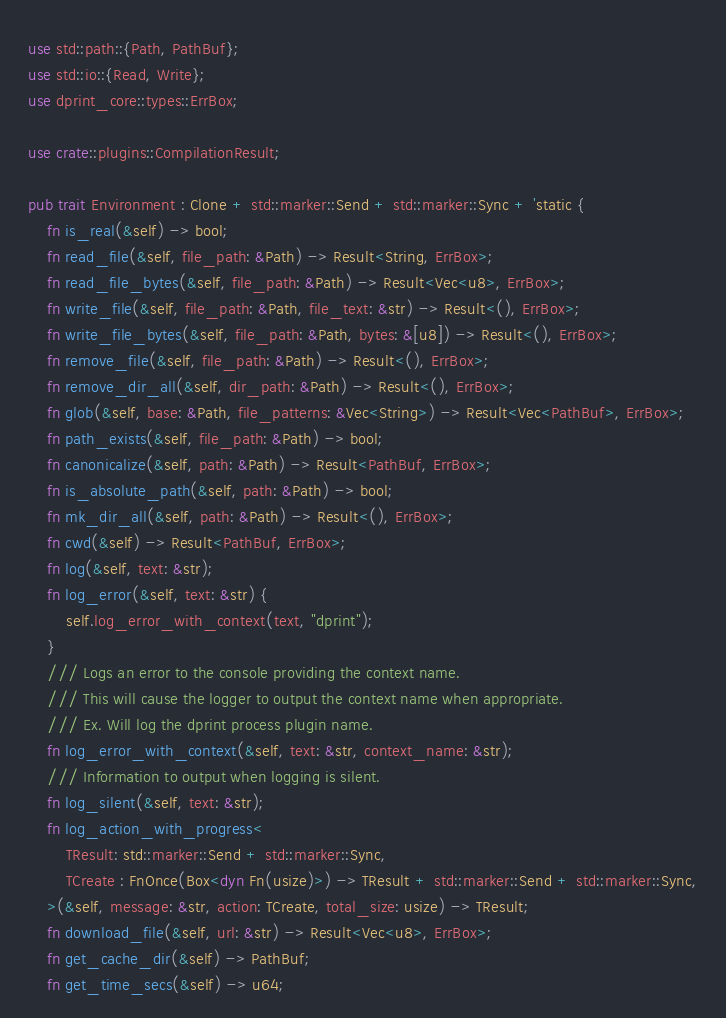<code> <loc_0><loc_0><loc_500><loc_500><_Rust_>use std::path::{Path, PathBuf};
use std::io::{Read, Write};
use dprint_core::types::ErrBox;

use crate::plugins::CompilationResult;

pub trait Environment : Clone + std::marker::Send + std::marker::Sync + 'static {
    fn is_real(&self) -> bool;
    fn read_file(&self, file_path: &Path) -> Result<String, ErrBox>;
    fn read_file_bytes(&self, file_path: &Path) -> Result<Vec<u8>, ErrBox>;
    fn write_file(&self, file_path: &Path, file_text: &str) -> Result<(), ErrBox>;
    fn write_file_bytes(&self, file_path: &Path, bytes: &[u8]) -> Result<(), ErrBox>;
    fn remove_file(&self, file_path: &Path) -> Result<(), ErrBox>;
    fn remove_dir_all(&self, dir_path: &Path) -> Result<(), ErrBox>;
    fn glob(&self, base: &Path, file_patterns: &Vec<String>) -> Result<Vec<PathBuf>, ErrBox>;
    fn path_exists(&self, file_path: &Path) -> bool;
    fn canonicalize(&self, path: &Path) -> Result<PathBuf, ErrBox>;
    fn is_absolute_path(&self, path: &Path) -> bool;
    fn mk_dir_all(&self, path: &Path) -> Result<(), ErrBox>;
    fn cwd(&self) -> Result<PathBuf, ErrBox>;
    fn log(&self, text: &str);
    fn log_error(&self, text: &str) {
        self.log_error_with_context(text, "dprint");
    }
    /// Logs an error to the console providing the context name.
    /// This will cause the logger to output the context name when appropriate.
    /// Ex. Will log the dprint process plugin name.
    fn log_error_with_context(&self, text: &str, context_name: &str);
    /// Information to output when logging is silent.
    fn log_silent(&self, text: &str);
    fn log_action_with_progress<
        TResult: std::marker::Send + std::marker::Sync,
        TCreate : FnOnce(Box<dyn Fn(usize)>) -> TResult + std::marker::Send + std::marker::Sync,
    >(&self, message: &str, action: TCreate, total_size: usize) -> TResult;
    fn download_file(&self, url: &str) -> Result<Vec<u8>, ErrBox>;
    fn get_cache_dir(&self) -> PathBuf;
    fn get_time_secs(&self) -> u64;</code> 